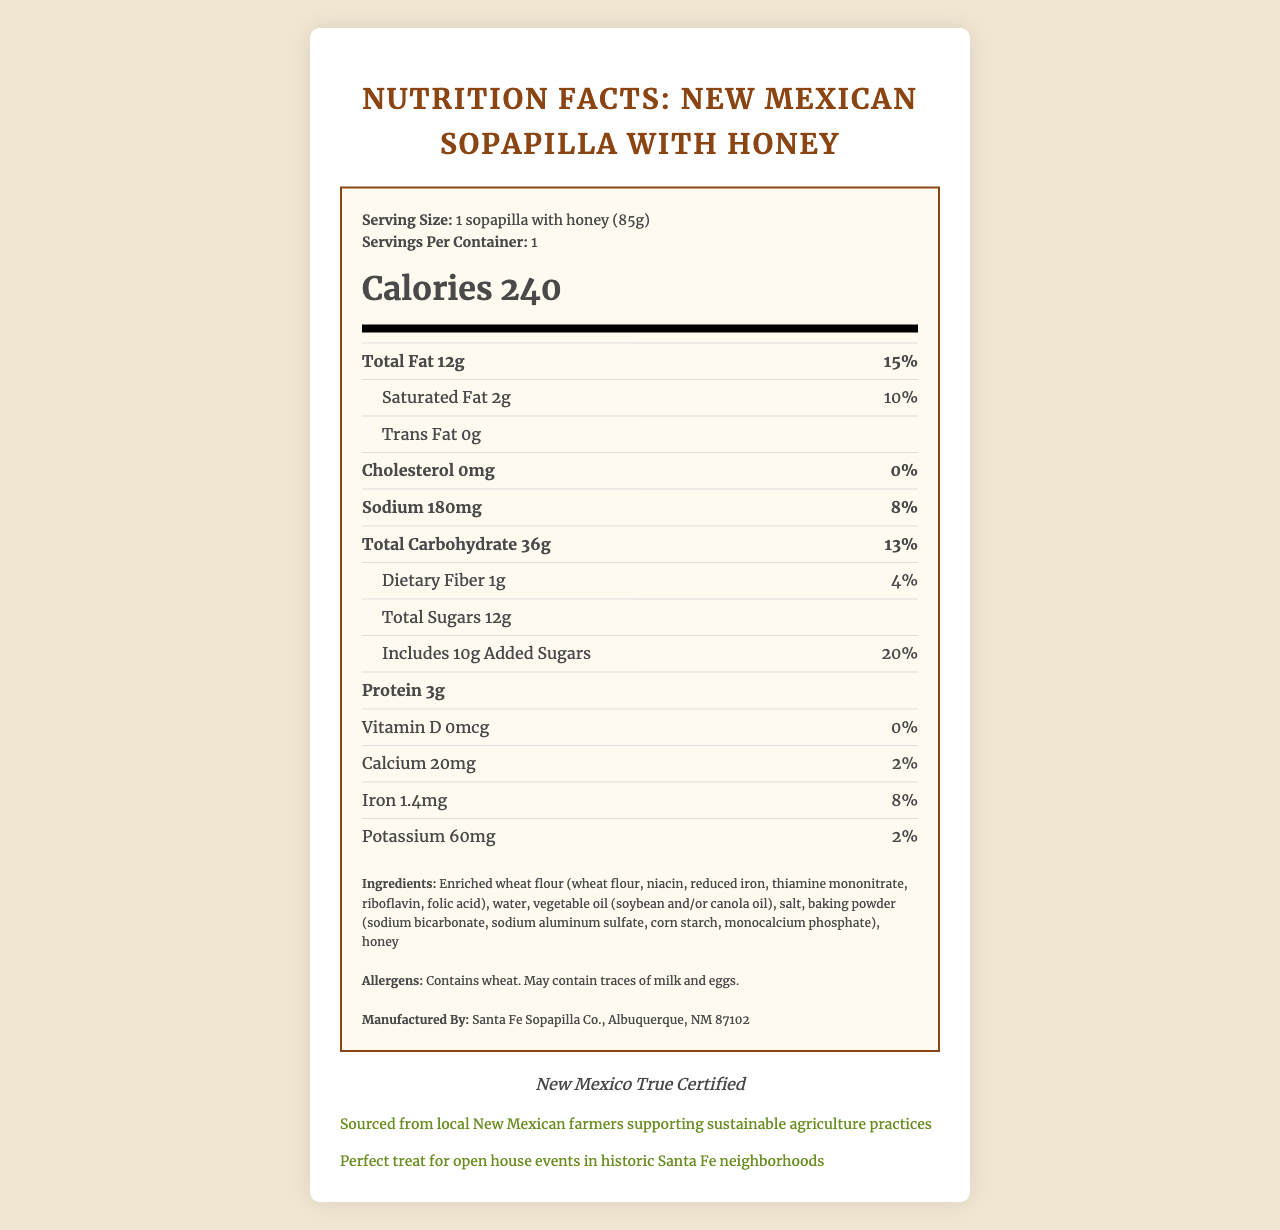what is the serving size? The serving size is stated at the top of the Nutrition Facts section.
Answer: 1 sopapilla with honey (85g) how many calories are in one serving? The number of calories is displayed prominently within the Nutrition Facts section.
Answer: 240 what is the total fat content? The total fat content is listed under the nutrient section in the Nutrition Facts.
Answer: 12g what percentage of daily value does saturated fat represent? The percentage daily value for saturated fat is shown next to the amount under the nutrient section.
Answer: 10% how much protein is in one serving? The protein content is listed towards the end of the nutrient section in the Nutrition Facts.
Answer: 3g what is the sodium content in milligrams? The sodium content is indicated under the nutrient section and given in milligrams.
Answer: 180mg which ingredient is listed first? The list of ingredients starts with enriched wheat flour, as mentioned in the ingredients section.
Answer: Enriched wheat flour how many grams of added sugars are in one serving? The amount of added sugars is listed directly under the total sugars in the nutrient section.
Answer: 10g where is the product manufactured? A. Santa Fe, NM B. Albuquerque, NM C. Las Cruces, NM D. Taos, NM Albuquerque, NM is indicated as the location of manufacture under "Manufactured By."
Answer: B what is the certification of the product? A. USDA Organic B. New Mexico True Certified C. Gluten-Free D. Non-GMO New Mexico True Certified is mentioned in the certifications section.
Answer: B does this product contain any milk or eggs? The allergen information states that the product may contain traces of milk and eggs.
Answer: May contain traces of milk and eggs is there any vitamin D in this product? The vitamin D content is listed as 0mcg.
Answer: No does the document say the product supports sustainable agriculture practices? It is mentioned in the political note that the product is sourced from local New Mexican farmers supporting sustainable agriculture practices.
Answer: Yes can we determine the exact price of the product from this document? The document does not provide any pricing information.
Answer: Cannot be determined summarize the main points of the document. The main points cover the detailed nutritional information, manufacturing and ingredient details, certifications, and notes on its relevance to sustainable practices and real estate connection.
Answer: The document provides the nutrition facts for a traditional New Mexican sopapilla with honey, including serving size, calorie content, and breakdown of various nutrients. It lists the ingredients, allergens, and manufacturing details, along with special notes on certifications, political support for local farmers, and a suggestion for real estate open house events. 